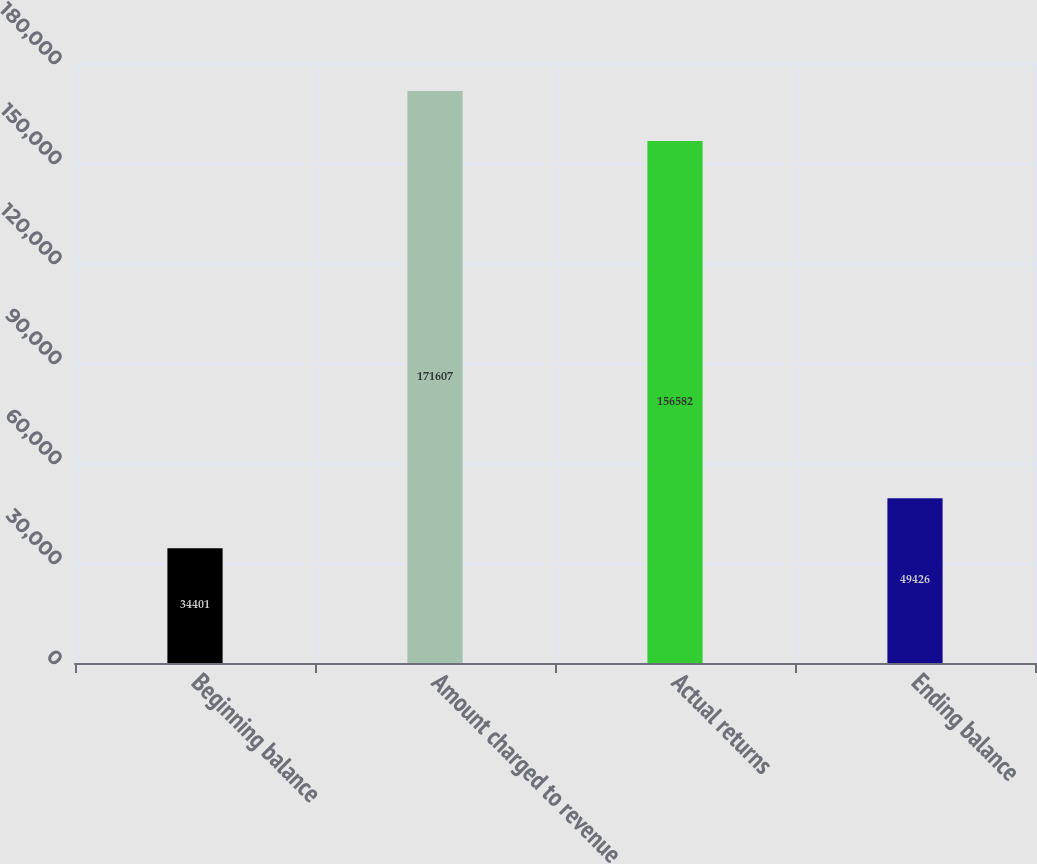Convert chart to OTSL. <chart><loc_0><loc_0><loc_500><loc_500><bar_chart><fcel>Beginning balance<fcel>Amount charged to revenue<fcel>Actual returns<fcel>Ending balance<nl><fcel>34401<fcel>171607<fcel>156582<fcel>49426<nl></chart> 